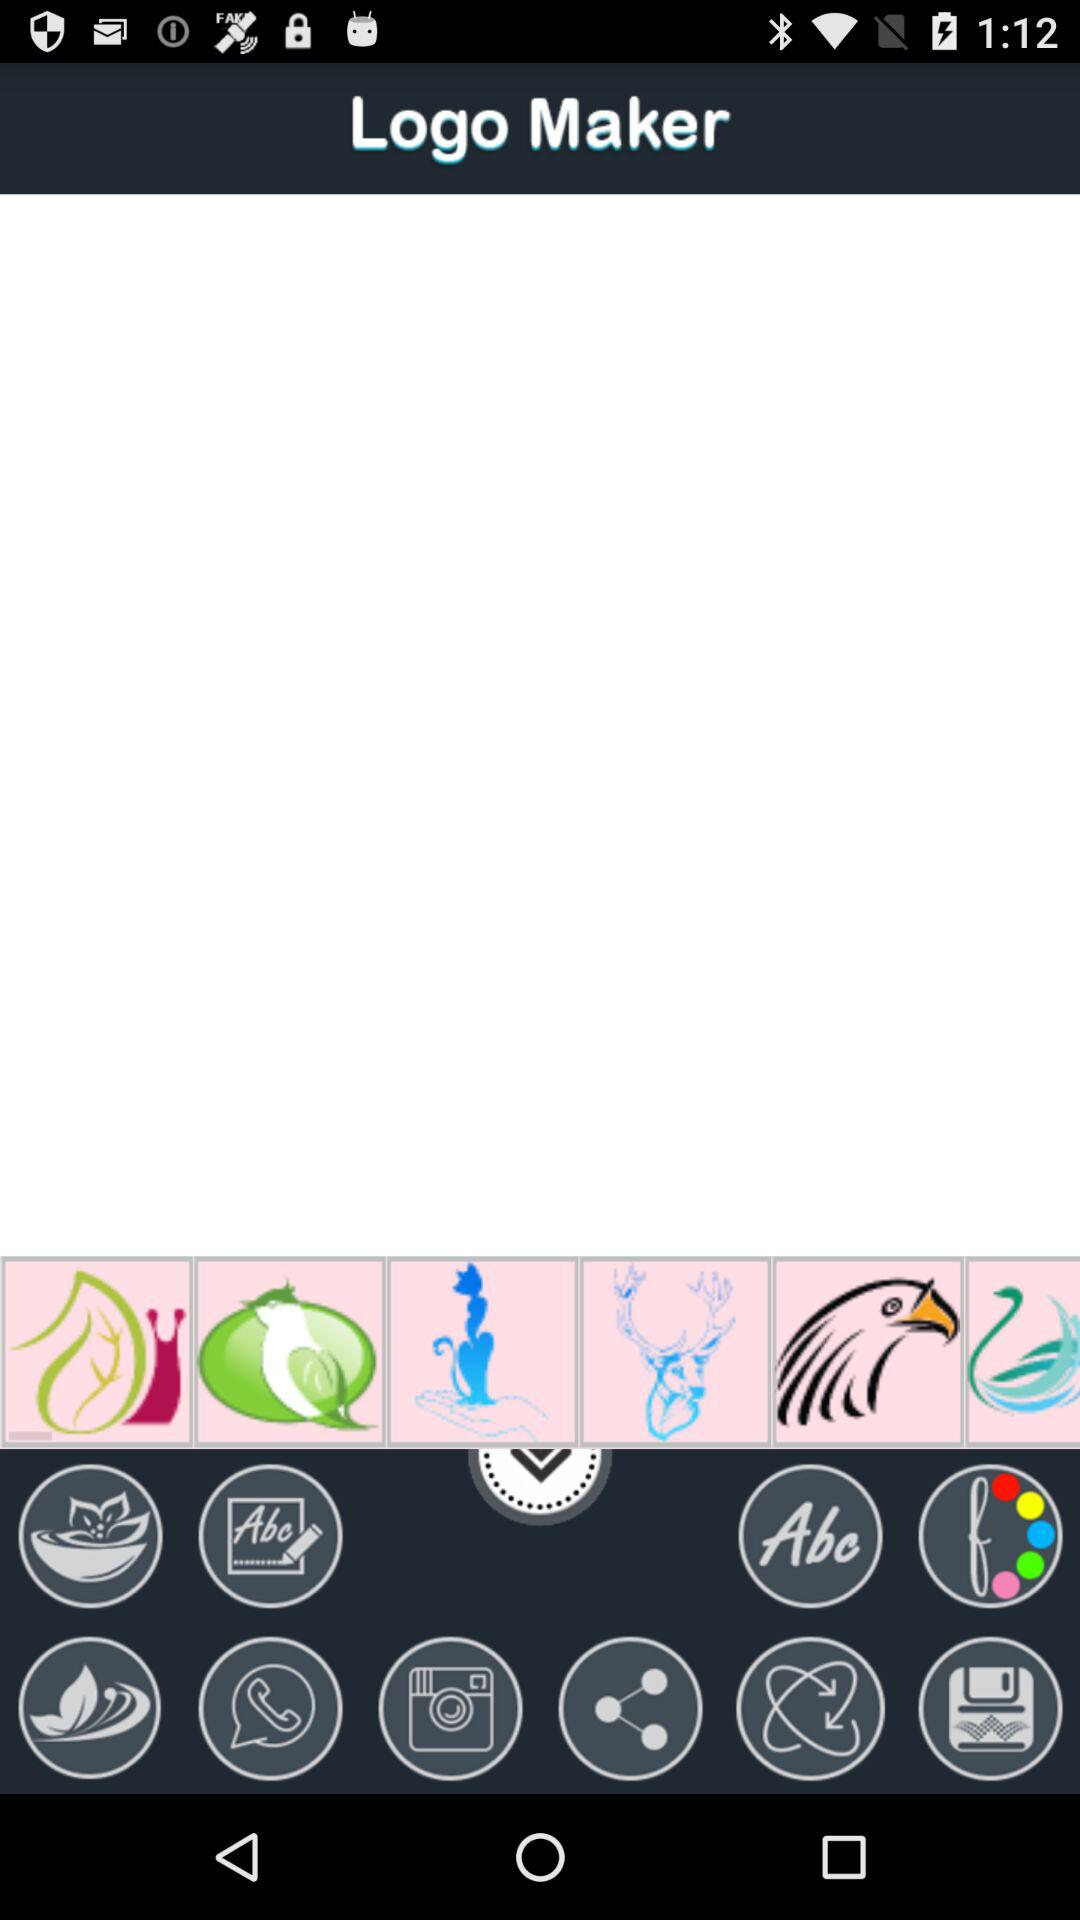Which logo is taller, the floral design or the sticker?
Answer the question using a single word or phrase. Floral design 